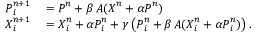Convert formula to latex. <formula><loc_0><loc_0><loc_500><loc_500>\begin{array} { r l } { { P } _ { i } ^ { n + 1 } } & = { P } ^ { n } + \beta \, { A } ( { X } ^ { n } + \alpha { P } ^ { n } ) } \\ { { X } _ { i } ^ { n + 1 } } & = { X } _ { i } ^ { n } + \alpha { P } _ { i } ^ { n } + \gamma \left ( { P } _ { i } ^ { n } + \beta \, { A } ( { X } _ { i } ^ { n } + \alpha { P } _ { i } ^ { n } ) \right ) . } \end{array}</formula> 